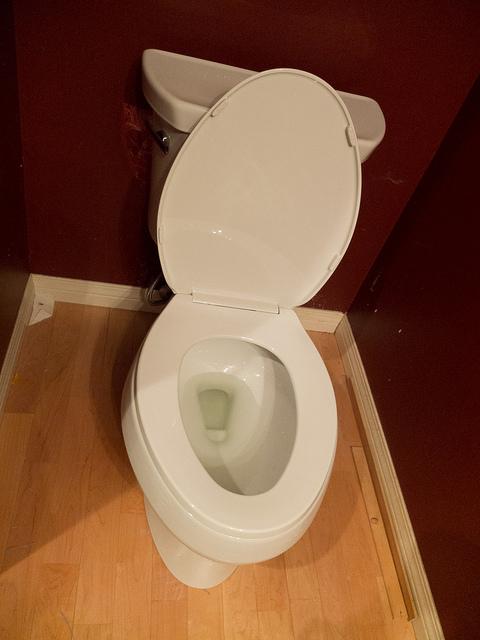Is the toilet lid up or down?
Give a very brief answer. Up. What are the walls made from?
Write a very short answer. Drywall. Is this a full bathroom?
Short answer required. No. What is the toilet doing?
Quick response, please. Nothing. What side of the toilet is the door on?
Answer briefly. Left. 